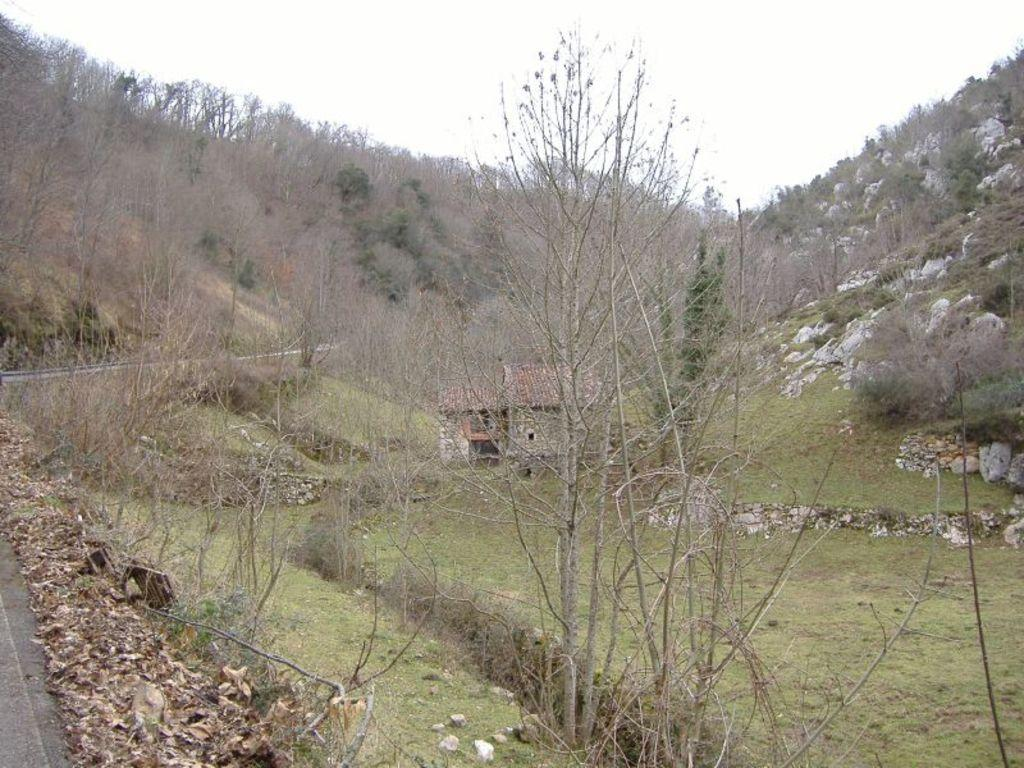What type of structure is in the picture? There is a house in the picture. What can be seen on the left side of the picture? There is a road on the left side of the picture. What type of vegetation is present in the picture? There are trees in the picture. What is the color of the grass in the picture? There is green grass in the picture. What is visible in the sky in the picture? There are clouds visible in the sky. What type of linen is being used for the feast in the picture? There is no feast or linen present in the picture; it features a house, road, trees, grass, and clouds. 